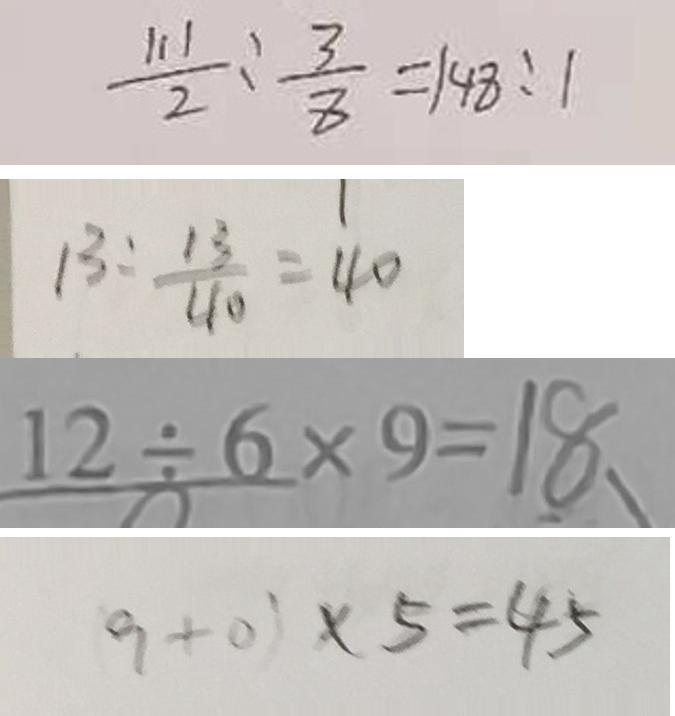<formula> <loc_0><loc_0><loc_500><loc_500>\frac { 1 1 1 } { 2 } : \frac { 3 } { 8 } = 1 4 8 : 1 
 1 3 : \frac { 1 3 } { 4 0 } = 4 0 
 1 2 \div 6 \times 9 = 1 8 
 ( 9 + 0 ) \times 5 = 4 5</formula> 